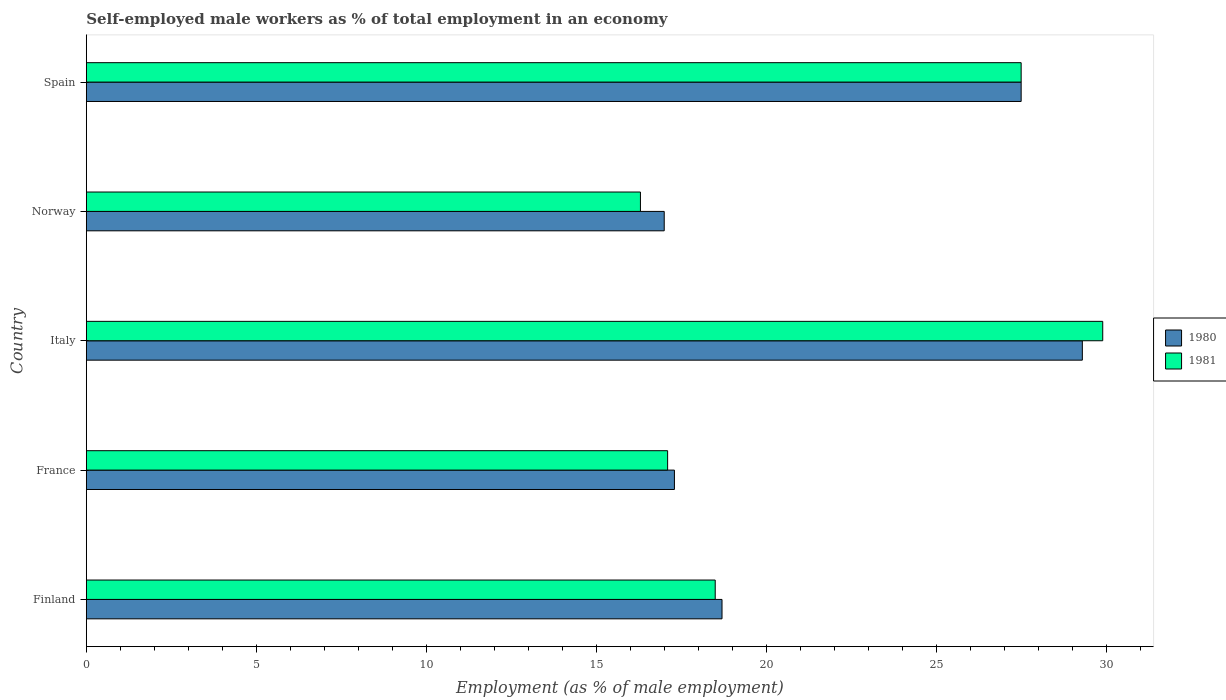Are the number of bars on each tick of the Y-axis equal?
Ensure brevity in your answer.  Yes. How many bars are there on the 3rd tick from the top?
Give a very brief answer. 2. How many bars are there on the 4th tick from the bottom?
Give a very brief answer. 2. What is the label of the 4th group of bars from the top?
Your answer should be compact. France. What is the percentage of self-employed male workers in 1980 in Italy?
Your answer should be compact. 29.3. Across all countries, what is the maximum percentage of self-employed male workers in 1981?
Your answer should be very brief. 29.9. Across all countries, what is the minimum percentage of self-employed male workers in 1981?
Provide a succinct answer. 16.3. In which country was the percentage of self-employed male workers in 1981 maximum?
Provide a succinct answer. Italy. In which country was the percentage of self-employed male workers in 1981 minimum?
Your answer should be compact. Norway. What is the total percentage of self-employed male workers in 1980 in the graph?
Offer a very short reply. 109.8. What is the difference between the percentage of self-employed male workers in 1980 in France and that in Norway?
Your response must be concise. 0.3. What is the difference between the percentage of self-employed male workers in 1980 in Spain and the percentage of self-employed male workers in 1981 in Norway?
Offer a terse response. 11.2. What is the average percentage of self-employed male workers in 1980 per country?
Your response must be concise. 21.96. What is the difference between the percentage of self-employed male workers in 1980 and percentage of self-employed male workers in 1981 in Norway?
Your answer should be compact. 0.7. In how many countries, is the percentage of self-employed male workers in 1981 greater than 20 %?
Provide a succinct answer. 2. What is the ratio of the percentage of self-employed male workers in 1981 in Italy to that in Spain?
Provide a short and direct response. 1.09. Is the difference between the percentage of self-employed male workers in 1980 in France and Spain greater than the difference between the percentage of self-employed male workers in 1981 in France and Spain?
Offer a terse response. Yes. What is the difference between the highest and the second highest percentage of self-employed male workers in 1980?
Offer a very short reply. 1.8. What is the difference between the highest and the lowest percentage of self-employed male workers in 1980?
Provide a succinct answer. 12.3. Is the sum of the percentage of self-employed male workers in 1980 in France and Spain greater than the maximum percentage of self-employed male workers in 1981 across all countries?
Give a very brief answer. Yes. What does the 2nd bar from the top in Norway represents?
Give a very brief answer. 1980. What does the 2nd bar from the bottom in Norway represents?
Offer a terse response. 1981. How many countries are there in the graph?
Offer a very short reply. 5. What is the difference between two consecutive major ticks on the X-axis?
Offer a very short reply. 5. Does the graph contain any zero values?
Your answer should be compact. No. Where does the legend appear in the graph?
Ensure brevity in your answer.  Center right. What is the title of the graph?
Make the answer very short. Self-employed male workers as % of total employment in an economy. What is the label or title of the X-axis?
Provide a succinct answer. Employment (as % of male employment). What is the Employment (as % of male employment) in 1980 in Finland?
Provide a short and direct response. 18.7. What is the Employment (as % of male employment) of 1981 in Finland?
Your response must be concise. 18.5. What is the Employment (as % of male employment) in 1980 in France?
Offer a very short reply. 17.3. What is the Employment (as % of male employment) in 1981 in France?
Provide a short and direct response. 17.1. What is the Employment (as % of male employment) of 1980 in Italy?
Ensure brevity in your answer.  29.3. What is the Employment (as % of male employment) of 1981 in Italy?
Give a very brief answer. 29.9. What is the Employment (as % of male employment) of 1980 in Norway?
Provide a succinct answer. 17. What is the Employment (as % of male employment) in 1981 in Norway?
Keep it short and to the point. 16.3. What is the Employment (as % of male employment) in 1980 in Spain?
Ensure brevity in your answer.  27.5. What is the Employment (as % of male employment) of 1981 in Spain?
Keep it short and to the point. 27.5. Across all countries, what is the maximum Employment (as % of male employment) in 1980?
Your response must be concise. 29.3. Across all countries, what is the maximum Employment (as % of male employment) in 1981?
Your answer should be very brief. 29.9. Across all countries, what is the minimum Employment (as % of male employment) in 1980?
Provide a short and direct response. 17. Across all countries, what is the minimum Employment (as % of male employment) in 1981?
Provide a short and direct response. 16.3. What is the total Employment (as % of male employment) of 1980 in the graph?
Provide a short and direct response. 109.8. What is the total Employment (as % of male employment) of 1981 in the graph?
Your response must be concise. 109.3. What is the difference between the Employment (as % of male employment) in 1980 in Finland and that in France?
Give a very brief answer. 1.4. What is the difference between the Employment (as % of male employment) of 1980 in Finland and that in Italy?
Provide a short and direct response. -10.6. What is the difference between the Employment (as % of male employment) in 1981 in Finland and that in Italy?
Offer a terse response. -11.4. What is the difference between the Employment (as % of male employment) in 1980 in Finland and that in Norway?
Offer a terse response. 1.7. What is the difference between the Employment (as % of male employment) of 1980 in Finland and that in Spain?
Offer a very short reply. -8.8. What is the difference between the Employment (as % of male employment) in 1980 in France and that in Italy?
Make the answer very short. -12. What is the difference between the Employment (as % of male employment) in 1980 in France and that in Norway?
Make the answer very short. 0.3. What is the difference between the Employment (as % of male employment) of 1981 in France and that in Norway?
Ensure brevity in your answer.  0.8. What is the difference between the Employment (as % of male employment) of 1981 in France and that in Spain?
Offer a terse response. -10.4. What is the difference between the Employment (as % of male employment) of 1980 in Italy and that in Norway?
Make the answer very short. 12.3. What is the difference between the Employment (as % of male employment) in 1981 in Italy and that in Norway?
Your response must be concise. 13.6. What is the difference between the Employment (as % of male employment) in 1980 in Italy and that in Spain?
Your response must be concise. 1.8. What is the difference between the Employment (as % of male employment) in 1981 in Italy and that in Spain?
Give a very brief answer. 2.4. What is the difference between the Employment (as % of male employment) of 1980 in Norway and that in Spain?
Make the answer very short. -10.5. What is the difference between the Employment (as % of male employment) of 1981 in Norway and that in Spain?
Provide a succinct answer. -11.2. What is the difference between the Employment (as % of male employment) in 1980 in Finland and the Employment (as % of male employment) in 1981 in Spain?
Offer a very short reply. -8.8. What is the difference between the Employment (as % of male employment) of 1980 in France and the Employment (as % of male employment) of 1981 in Norway?
Provide a short and direct response. 1. What is the difference between the Employment (as % of male employment) in 1980 in Italy and the Employment (as % of male employment) in 1981 in Norway?
Make the answer very short. 13. What is the difference between the Employment (as % of male employment) in 1980 in Italy and the Employment (as % of male employment) in 1981 in Spain?
Your response must be concise. 1.8. What is the average Employment (as % of male employment) in 1980 per country?
Keep it short and to the point. 21.96. What is the average Employment (as % of male employment) of 1981 per country?
Give a very brief answer. 21.86. What is the difference between the Employment (as % of male employment) of 1980 and Employment (as % of male employment) of 1981 in Italy?
Offer a very short reply. -0.6. What is the difference between the Employment (as % of male employment) in 1980 and Employment (as % of male employment) in 1981 in Norway?
Make the answer very short. 0.7. What is the difference between the Employment (as % of male employment) in 1980 and Employment (as % of male employment) in 1981 in Spain?
Give a very brief answer. 0. What is the ratio of the Employment (as % of male employment) of 1980 in Finland to that in France?
Provide a short and direct response. 1.08. What is the ratio of the Employment (as % of male employment) in 1981 in Finland to that in France?
Provide a short and direct response. 1.08. What is the ratio of the Employment (as % of male employment) of 1980 in Finland to that in Italy?
Your answer should be compact. 0.64. What is the ratio of the Employment (as % of male employment) of 1981 in Finland to that in Italy?
Offer a terse response. 0.62. What is the ratio of the Employment (as % of male employment) in 1980 in Finland to that in Norway?
Your answer should be very brief. 1.1. What is the ratio of the Employment (as % of male employment) of 1981 in Finland to that in Norway?
Your response must be concise. 1.14. What is the ratio of the Employment (as % of male employment) of 1980 in Finland to that in Spain?
Your response must be concise. 0.68. What is the ratio of the Employment (as % of male employment) of 1981 in Finland to that in Spain?
Provide a succinct answer. 0.67. What is the ratio of the Employment (as % of male employment) in 1980 in France to that in Italy?
Ensure brevity in your answer.  0.59. What is the ratio of the Employment (as % of male employment) of 1981 in France to that in Italy?
Ensure brevity in your answer.  0.57. What is the ratio of the Employment (as % of male employment) in 1980 in France to that in Norway?
Provide a succinct answer. 1.02. What is the ratio of the Employment (as % of male employment) in 1981 in France to that in Norway?
Offer a terse response. 1.05. What is the ratio of the Employment (as % of male employment) in 1980 in France to that in Spain?
Give a very brief answer. 0.63. What is the ratio of the Employment (as % of male employment) in 1981 in France to that in Spain?
Your answer should be compact. 0.62. What is the ratio of the Employment (as % of male employment) in 1980 in Italy to that in Norway?
Offer a terse response. 1.72. What is the ratio of the Employment (as % of male employment) in 1981 in Italy to that in Norway?
Make the answer very short. 1.83. What is the ratio of the Employment (as % of male employment) in 1980 in Italy to that in Spain?
Make the answer very short. 1.07. What is the ratio of the Employment (as % of male employment) in 1981 in Italy to that in Spain?
Offer a very short reply. 1.09. What is the ratio of the Employment (as % of male employment) of 1980 in Norway to that in Spain?
Your answer should be very brief. 0.62. What is the ratio of the Employment (as % of male employment) in 1981 in Norway to that in Spain?
Ensure brevity in your answer.  0.59. What is the difference between the highest and the lowest Employment (as % of male employment) of 1980?
Your answer should be compact. 12.3. What is the difference between the highest and the lowest Employment (as % of male employment) of 1981?
Provide a succinct answer. 13.6. 